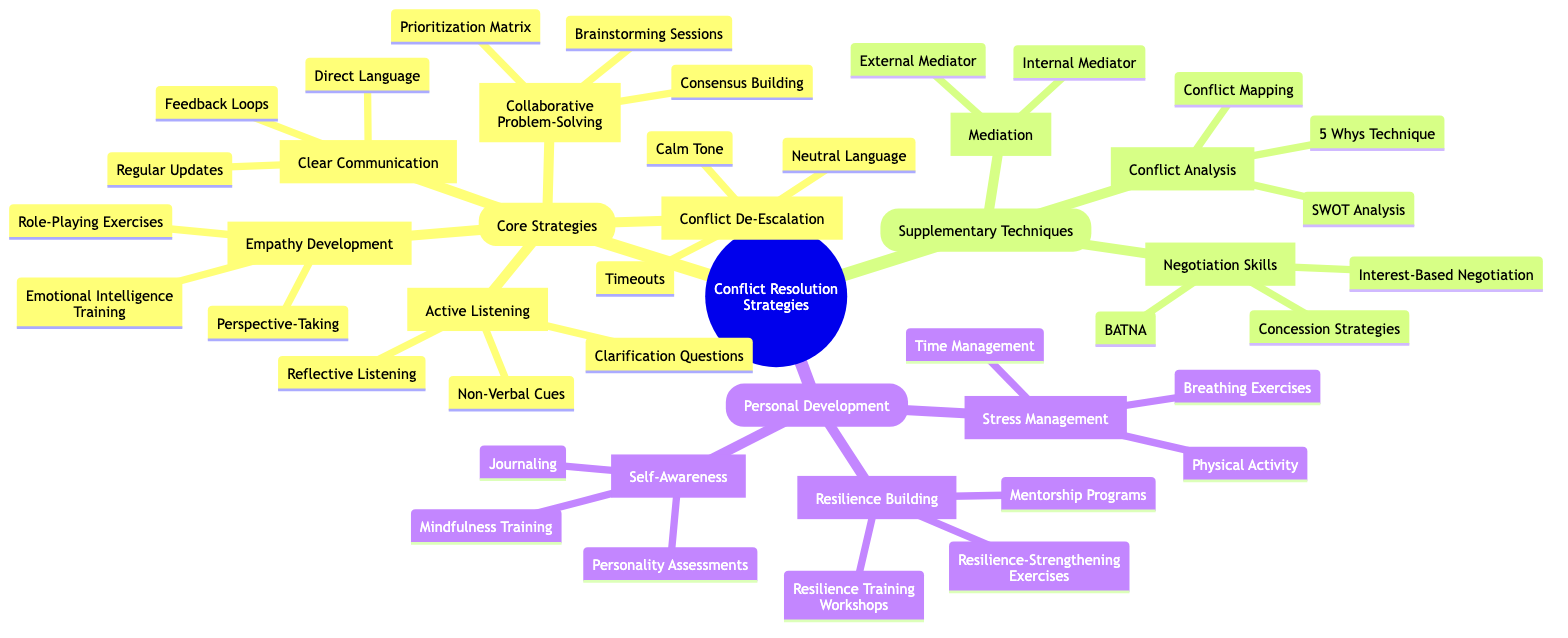What are the core strategies listed in the diagram? The diagram lists five core strategies under the "Core Strategies" category: Active Listening, Empathy Development, Clear Communication, Collaborative Problem-Solving, and Conflict De-Escalation.
Answer: Active Listening, Empathy Development, Clear Communication, Collaborative Problem-Solving, Conflict De-Escalation How many techniques are listed under Active Listening? The "Active Listening" node contains three techniques: Reflective Listening, Non-Verbal Cues, and Clarification Questions. Thus, there are three techniques listed.
Answer: 3 What is one method for Empathy Development? Under the "Empathy Development" node, one of the methods listed is Emotional Intelligence Training.
Answer: Emotional Intelligence Training Which supplementary technique involves using a neutral third party? The "Mediation" node describes the supplementary technique that involves using a neutral third party to facilitate conflict resolution.
Answer: Mediation How many elements are in the "Personal Development" category? The "Personal Development" category includes three elements: Self-Awareness, Stress Management, and Resilience Building. So, there are three elements in this category.
Answer: 3 What component is part of Clear Communication? A component listed under "Clear Communication" is Regular Updates, which helps to foster open and transparent communication.
Answer: Regular Updates Which technique is used for Conflict De-Escalation? One of the techniques mentioned under the "Conflict De-Escalation" node is Calm Tone, which is used to reduce the intensity of conflicts.
Answer: Calm Tone What is the first approach under Collaborative Problem-Solving? The first approach listed under the "Collaborative Problem-Solving" node is Brainstorming Sessions, which encourages leaders to work together.
Answer: Brainstorming Sessions How does Negotiation Skills relate to Supplementary Techniques? "Negotiation Skills" is a key element under the "Supplementary Techniques" category, focusing on training leaders in effective negotiation for win-win outcomes.
Answer: Negotiation Skills 